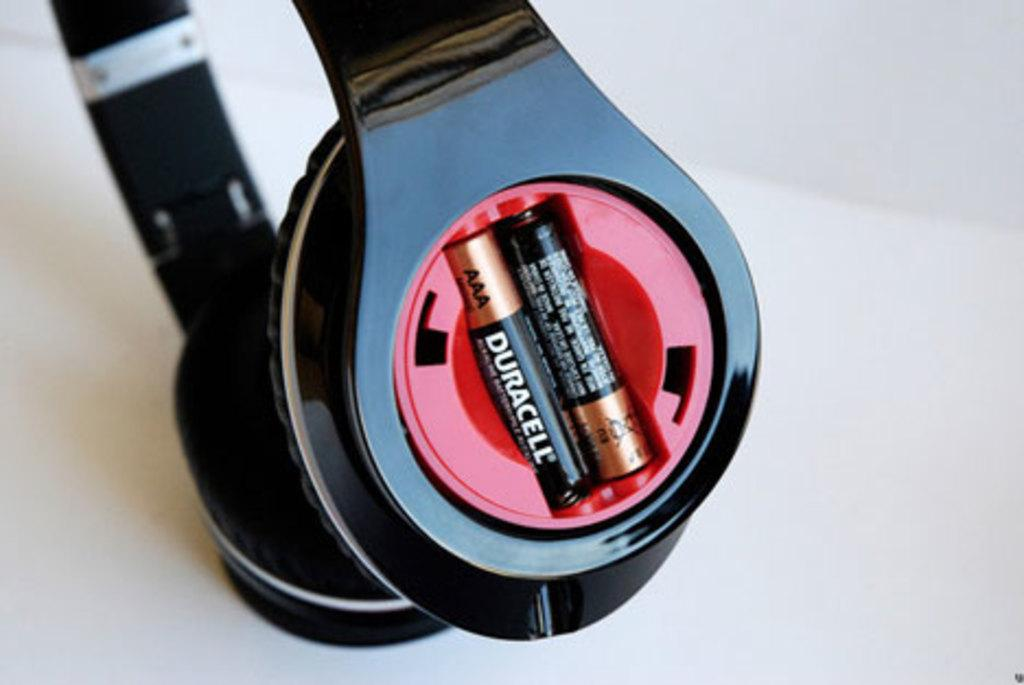<image>
Provide a brief description of the given image. two duracell batteries in a pair of over ear headphones. 